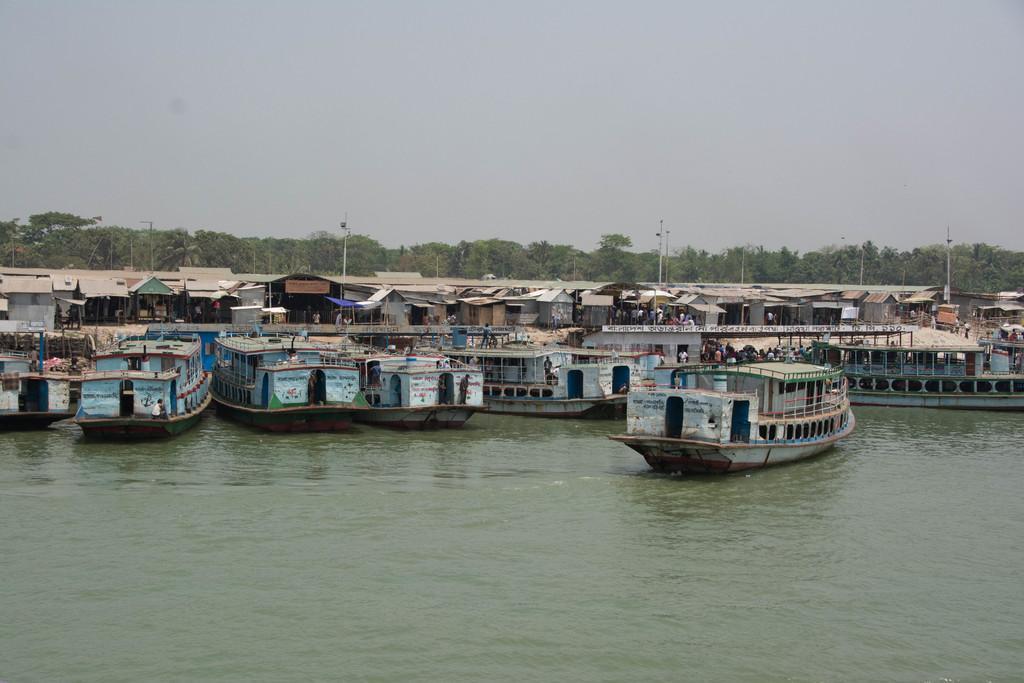How would you summarize this image in a sentence or two? In this picture we can see a few boats in water. There are few houses, poles and trees are visible in the background. 